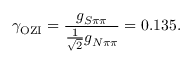<formula> <loc_0><loc_0><loc_500><loc_500>\gamma _ { O Z I } = \frac { g _ { S \pi \pi } } { \frac { 1 } { \sqrt { 2 } } g _ { N \pi \pi } } = 0 . 1 3 5 .</formula> 